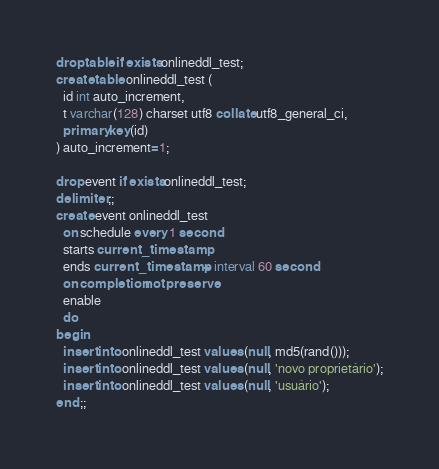<code> <loc_0><loc_0><loc_500><loc_500><_SQL_>drop table if exists onlineddl_test;
create table onlineddl_test (
  id int auto_increment,
  t varchar(128) charset utf8 collate utf8_general_ci,
  primary key(id)
) auto_increment=1;

drop event if exists onlineddl_test;
delimiter ;;
create event onlineddl_test
  on schedule every 1 second
  starts current_timestamp
  ends current_timestamp + interval 60 second
  on completion not preserve
  enable
  do
begin
  insert into onlineddl_test values (null, md5(rand()));
  insert into onlineddl_test values (null, 'novo proprietário');
  insert into onlineddl_test values (null, 'usuário');
end ;;
</code> 